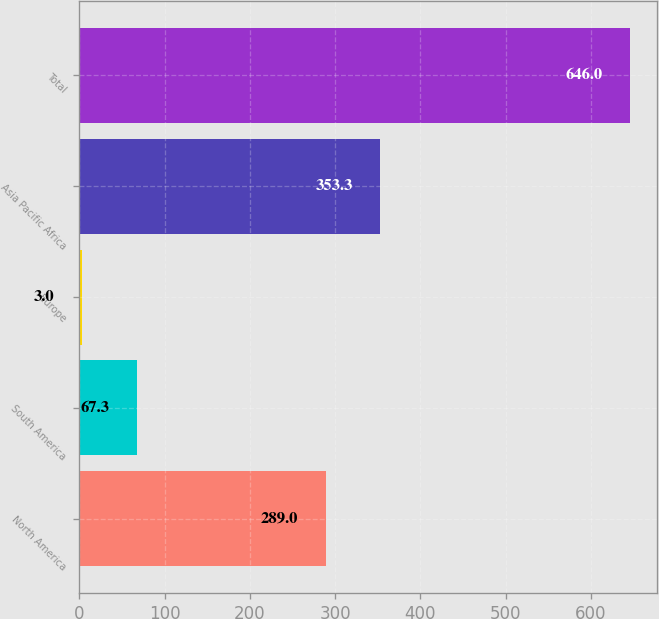Convert chart to OTSL. <chart><loc_0><loc_0><loc_500><loc_500><bar_chart><fcel>North America<fcel>South America<fcel>Europe<fcel>Asia Pacific Africa<fcel>Total<nl><fcel>289<fcel>67.3<fcel>3<fcel>353.3<fcel>646<nl></chart> 